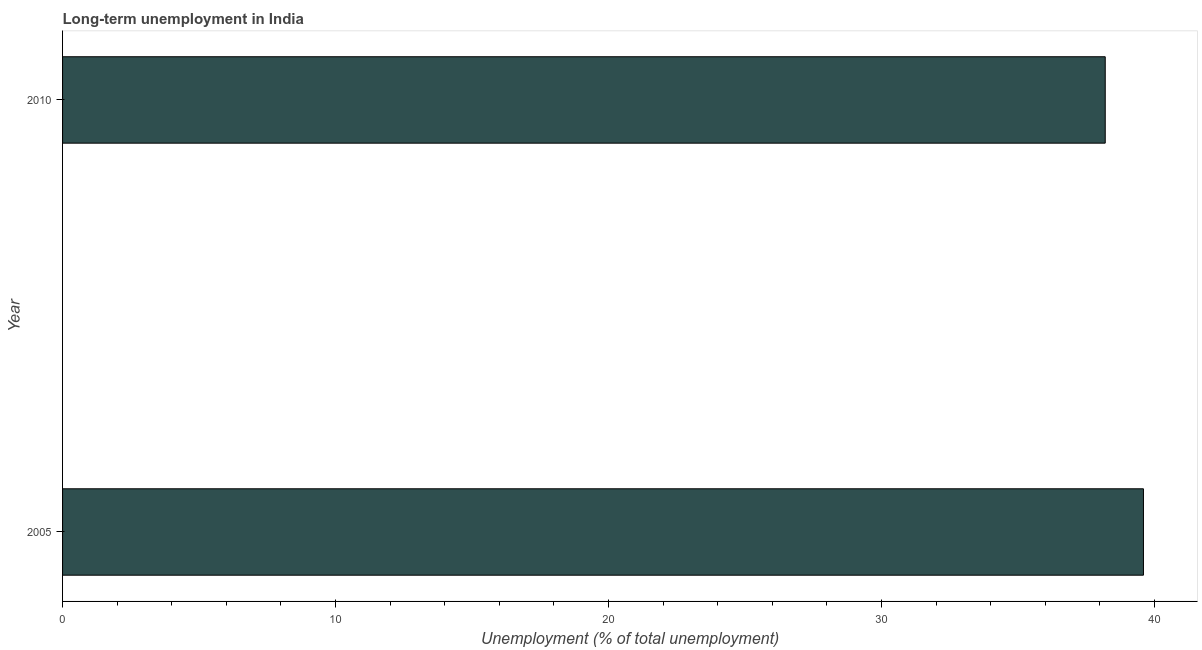Does the graph contain any zero values?
Provide a succinct answer. No. Does the graph contain grids?
Make the answer very short. No. What is the title of the graph?
Your answer should be compact. Long-term unemployment in India. What is the label or title of the X-axis?
Give a very brief answer. Unemployment (% of total unemployment). What is the long-term unemployment in 2005?
Make the answer very short. 39.6. Across all years, what is the maximum long-term unemployment?
Give a very brief answer. 39.6. Across all years, what is the minimum long-term unemployment?
Keep it short and to the point. 38.2. In which year was the long-term unemployment minimum?
Give a very brief answer. 2010. What is the sum of the long-term unemployment?
Provide a short and direct response. 77.8. What is the difference between the long-term unemployment in 2005 and 2010?
Ensure brevity in your answer.  1.4. What is the average long-term unemployment per year?
Offer a very short reply. 38.9. What is the median long-term unemployment?
Your answer should be very brief. 38.9. Is the long-term unemployment in 2005 less than that in 2010?
Your response must be concise. No. How many bars are there?
Keep it short and to the point. 2. How many years are there in the graph?
Keep it short and to the point. 2. What is the difference between two consecutive major ticks on the X-axis?
Your answer should be compact. 10. Are the values on the major ticks of X-axis written in scientific E-notation?
Keep it short and to the point. No. What is the Unemployment (% of total unemployment) of 2005?
Offer a terse response. 39.6. What is the Unemployment (% of total unemployment) of 2010?
Ensure brevity in your answer.  38.2. What is the difference between the Unemployment (% of total unemployment) in 2005 and 2010?
Offer a terse response. 1.4. 